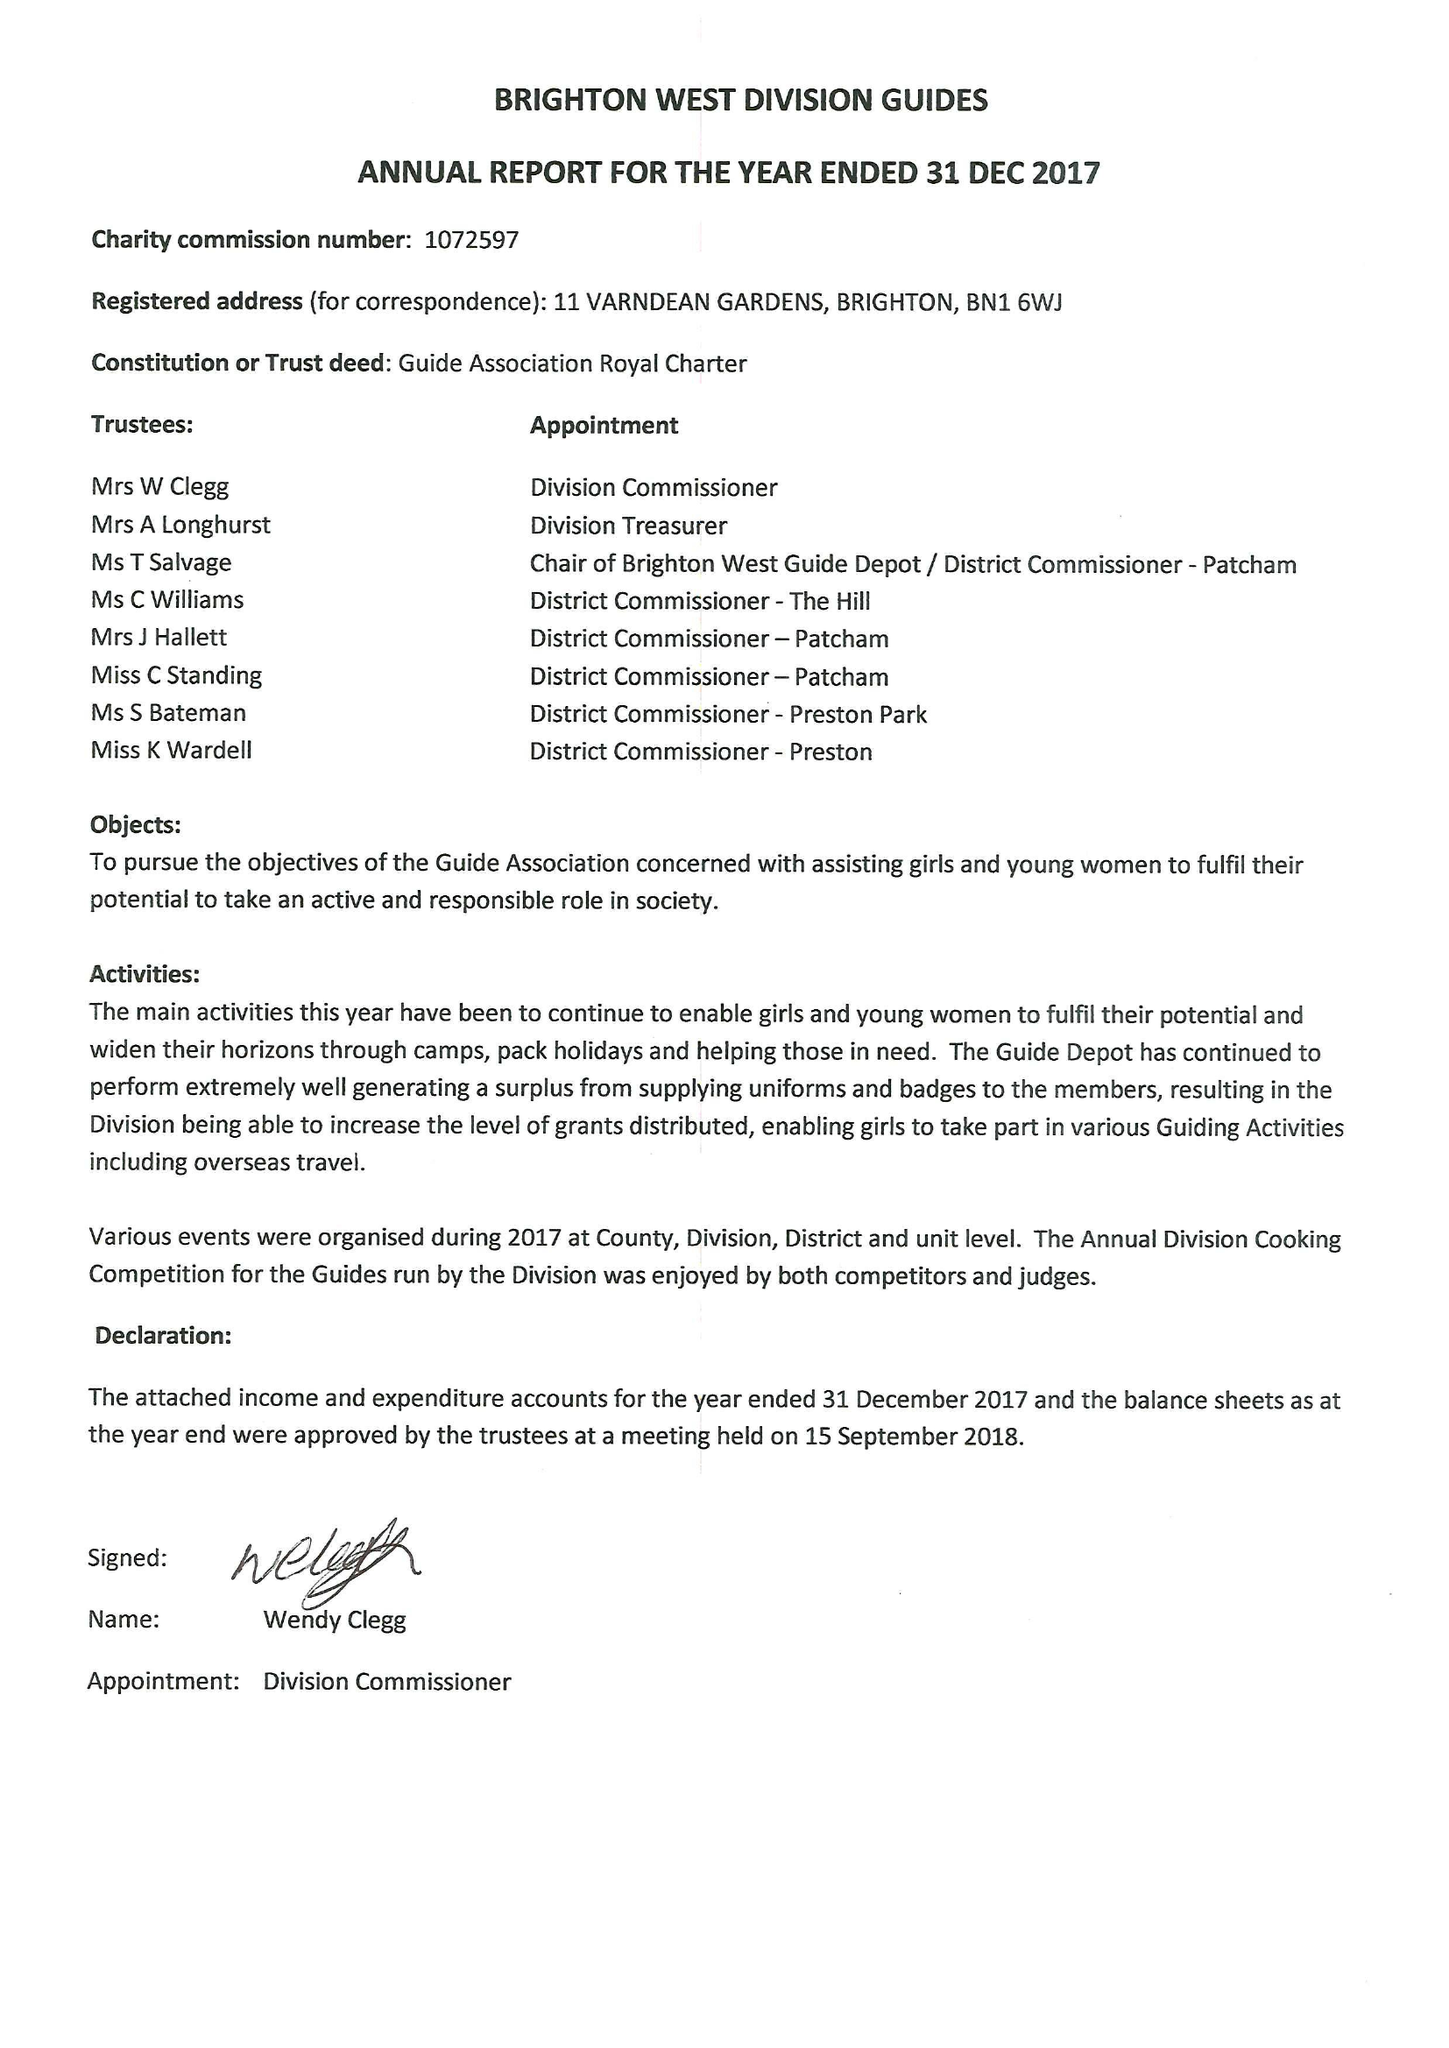What is the value for the report_date?
Answer the question using a single word or phrase. 2017-12-31 